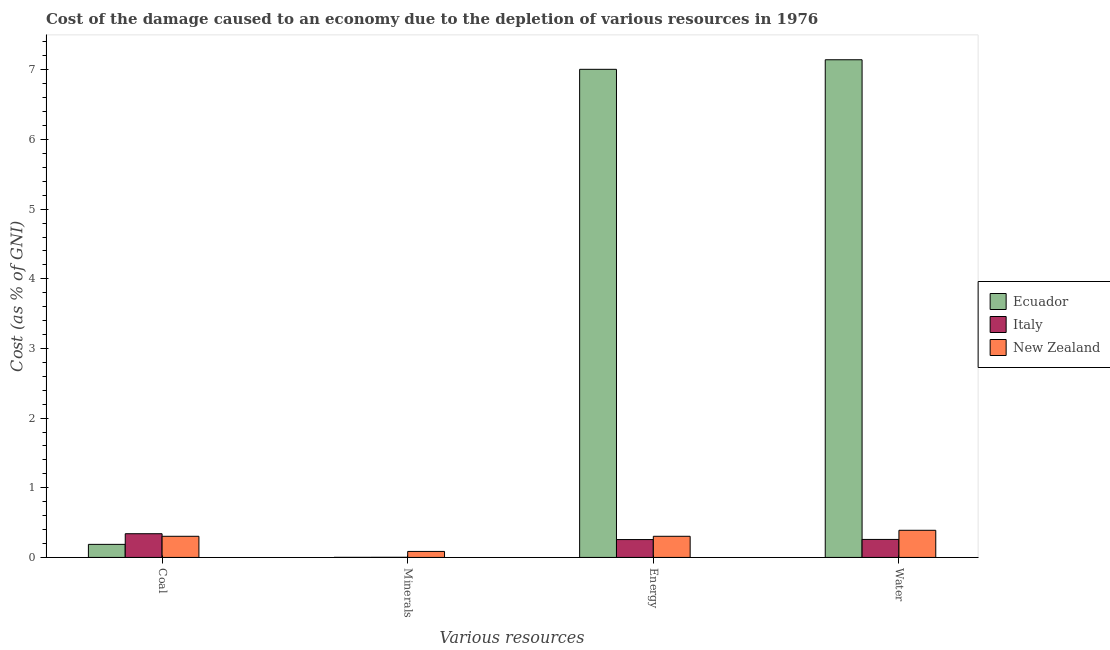How many different coloured bars are there?
Keep it short and to the point. 3. How many groups of bars are there?
Offer a terse response. 4. Are the number of bars on each tick of the X-axis equal?
Make the answer very short. Yes. What is the label of the 4th group of bars from the left?
Your response must be concise. Water. What is the cost of damage due to depletion of energy in Ecuador?
Keep it short and to the point. 7.01. Across all countries, what is the maximum cost of damage due to depletion of coal?
Your answer should be compact. 0.34. Across all countries, what is the minimum cost of damage due to depletion of energy?
Your response must be concise. 0.26. In which country was the cost of damage due to depletion of water maximum?
Offer a very short reply. Ecuador. In which country was the cost of damage due to depletion of minerals minimum?
Your response must be concise. Ecuador. What is the total cost of damage due to depletion of energy in the graph?
Your response must be concise. 7.57. What is the difference between the cost of damage due to depletion of water in Italy and that in Ecuador?
Provide a short and direct response. -6.89. What is the difference between the cost of damage due to depletion of energy in New Zealand and the cost of damage due to depletion of water in Italy?
Offer a terse response. 0.05. What is the average cost of damage due to depletion of water per country?
Make the answer very short. 2.6. What is the difference between the cost of damage due to depletion of coal and cost of damage due to depletion of energy in New Zealand?
Offer a terse response. -4.863200222998687e-5. In how many countries, is the cost of damage due to depletion of energy greater than 0.2 %?
Make the answer very short. 3. What is the ratio of the cost of damage due to depletion of energy in Ecuador to that in New Zealand?
Provide a succinct answer. 23.09. Is the cost of damage due to depletion of water in New Zealand less than that in Ecuador?
Provide a succinct answer. Yes. What is the difference between the highest and the second highest cost of damage due to depletion of energy?
Offer a very short reply. 6.7. What is the difference between the highest and the lowest cost of damage due to depletion of coal?
Make the answer very short. 0.15. In how many countries, is the cost of damage due to depletion of minerals greater than the average cost of damage due to depletion of minerals taken over all countries?
Your response must be concise. 1. What does the 3rd bar from the left in Minerals represents?
Your answer should be very brief. New Zealand. What does the 2nd bar from the right in Energy represents?
Your answer should be compact. Italy. Is it the case that in every country, the sum of the cost of damage due to depletion of coal and cost of damage due to depletion of minerals is greater than the cost of damage due to depletion of energy?
Keep it short and to the point. No. What is the difference between two consecutive major ticks on the Y-axis?
Your answer should be compact. 1. Are the values on the major ticks of Y-axis written in scientific E-notation?
Your answer should be very brief. No. Does the graph contain any zero values?
Offer a very short reply. No. How many legend labels are there?
Give a very brief answer. 3. What is the title of the graph?
Your answer should be compact. Cost of the damage caused to an economy due to the depletion of various resources in 1976 . Does "Spain" appear as one of the legend labels in the graph?
Make the answer very short. No. What is the label or title of the X-axis?
Make the answer very short. Various resources. What is the label or title of the Y-axis?
Offer a terse response. Cost (as % of GNI). What is the Cost (as % of GNI) of Ecuador in Coal?
Your response must be concise. 0.19. What is the Cost (as % of GNI) in Italy in Coal?
Your response must be concise. 0.34. What is the Cost (as % of GNI) of New Zealand in Coal?
Provide a short and direct response. 0.3. What is the Cost (as % of GNI) in Ecuador in Minerals?
Keep it short and to the point. 0. What is the Cost (as % of GNI) of Italy in Minerals?
Your response must be concise. 0. What is the Cost (as % of GNI) of New Zealand in Minerals?
Provide a succinct answer. 0.09. What is the Cost (as % of GNI) of Ecuador in Energy?
Provide a succinct answer. 7.01. What is the Cost (as % of GNI) of Italy in Energy?
Give a very brief answer. 0.26. What is the Cost (as % of GNI) of New Zealand in Energy?
Offer a very short reply. 0.3. What is the Cost (as % of GNI) of Ecuador in Water?
Your response must be concise. 7.14. What is the Cost (as % of GNI) in Italy in Water?
Ensure brevity in your answer.  0.26. What is the Cost (as % of GNI) of New Zealand in Water?
Ensure brevity in your answer.  0.39. Across all Various resources, what is the maximum Cost (as % of GNI) of Ecuador?
Your answer should be compact. 7.14. Across all Various resources, what is the maximum Cost (as % of GNI) of Italy?
Keep it short and to the point. 0.34. Across all Various resources, what is the maximum Cost (as % of GNI) in New Zealand?
Provide a succinct answer. 0.39. Across all Various resources, what is the minimum Cost (as % of GNI) in Ecuador?
Provide a short and direct response. 0. Across all Various resources, what is the minimum Cost (as % of GNI) of Italy?
Keep it short and to the point. 0. Across all Various resources, what is the minimum Cost (as % of GNI) in New Zealand?
Offer a very short reply. 0.09. What is the total Cost (as % of GNI) in Ecuador in the graph?
Your response must be concise. 14.34. What is the total Cost (as % of GNI) of Italy in the graph?
Your answer should be very brief. 0.86. What is the total Cost (as % of GNI) in New Zealand in the graph?
Ensure brevity in your answer.  1.08. What is the difference between the Cost (as % of GNI) of Ecuador in Coal and that in Minerals?
Provide a succinct answer. 0.19. What is the difference between the Cost (as % of GNI) of Italy in Coal and that in Minerals?
Provide a short and direct response. 0.34. What is the difference between the Cost (as % of GNI) in New Zealand in Coal and that in Minerals?
Give a very brief answer. 0.22. What is the difference between the Cost (as % of GNI) of Ecuador in Coal and that in Energy?
Offer a terse response. -6.82. What is the difference between the Cost (as % of GNI) in Italy in Coal and that in Energy?
Ensure brevity in your answer.  0.08. What is the difference between the Cost (as % of GNI) in New Zealand in Coal and that in Energy?
Provide a succinct answer. -0. What is the difference between the Cost (as % of GNI) in Ecuador in Coal and that in Water?
Keep it short and to the point. -6.96. What is the difference between the Cost (as % of GNI) of Italy in Coal and that in Water?
Offer a terse response. 0.08. What is the difference between the Cost (as % of GNI) of New Zealand in Coal and that in Water?
Your answer should be very brief. -0.09. What is the difference between the Cost (as % of GNI) in Ecuador in Minerals and that in Energy?
Your answer should be compact. -7.01. What is the difference between the Cost (as % of GNI) in Italy in Minerals and that in Energy?
Your answer should be compact. -0.25. What is the difference between the Cost (as % of GNI) of New Zealand in Minerals and that in Energy?
Provide a short and direct response. -0.22. What is the difference between the Cost (as % of GNI) of Ecuador in Minerals and that in Water?
Your answer should be compact. -7.14. What is the difference between the Cost (as % of GNI) in Italy in Minerals and that in Water?
Offer a terse response. -0.26. What is the difference between the Cost (as % of GNI) in New Zealand in Minerals and that in Water?
Make the answer very short. -0.3. What is the difference between the Cost (as % of GNI) in Ecuador in Energy and that in Water?
Provide a succinct answer. -0.14. What is the difference between the Cost (as % of GNI) in Italy in Energy and that in Water?
Offer a terse response. -0. What is the difference between the Cost (as % of GNI) of New Zealand in Energy and that in Water?
Your answer should be very brief. -0.09. What is the difference between the Cost (as % of GNI) in Ecuador in Coal and the Cost (as % of GNI) in Italy in Minerals?
Make the answer very short. 0.19. What is the difference between the Cost (as % of GNI) in Ecuador in Coal and the Cost (as % of GNI) in New Zealand in Minerals?
Offer a terse response. 0.1. What is the difference between the Cost (as % of GNI) in Italy in Coal and the Cost (as % of GNI) in New Zealand in Minerals?
Ensure brevity in your answer.  0.25. What is the difference between the Cost (as % of GNI) in Ecuador in Coal and the Cost (as % of GNI) in Italy in Energy?
Ensure brevity in your answer.  -0.07. What is the difference between the Cost (as % of GNI) of Ecuador in Coal and the Cost (as % of GNI) of New Zealand in Energy?
Your answer should be very brief. -0.12. What is the difference between the Cost (as % of GNI) of Italy in Coal and the Cost (as % of GNI) of New Zealand in Energy?
Provide a short and direct response. 0.04. What is the difference between the Cost (as % of GNI) in Ecuador in Coal and the Cost (as % of GNI) in Italy in Water?
Offer a terse response. -0.07. What is the difference between the Cost (as % of GNI) in Ecuador in Coal and the Cost (as % of GNI) in New Zealand in Water?
Ensure brevity in your answer.  -0.2. What is the difference between the Cost (as % of GNI) in Italy in Coal and the Cost (as % of GNI) in New Zealand in Water?
Your response must be concise. -0.05. What is the difference between the Cost (as % of GNI) of Ecuador in Minerals and the Cost (as % of GNI) of Italy in Energy?
Offer a terse response. -0.26. What is the difference between the Cost (as % of GNI) of Ecuador in Minerals and the Cost (as % of GNI) of New Zealand in Energy?
Keep it short and to the point. -0.3. What is the difference between the Cost (as % of GNI) of Italy in Minerals and the Cost (as % of GNI) of New Zealand in Energy?
Provide a short and direct response. -0.3. What is the difference between the Cost (as % of GNI) in Ecuador in Minerals and the Cost (as % of GNI) in Italy in Water?
Make the answer very short. -0.26. What is the difference between the Cost (as % of GNI) of Ecuador in Minerals and the Cost (as % of GNI) of New Zealand in Water?
Offer a very short reply. -0.39. What is the difference between the Cost (as % of GNI) of Italy in Minerals and the Cost (as % of GNI) of New Zealand in Water?
Your response must be concise. -0.39. What is the difference between the Cost (as % of GNI) in Ecuador in Energy and the Cost (as % of GNI) in Italy in Water?
Your answer should be compact. 6.75. What is the difference between the Cost (as % of GNI) of Ecuador in Energy and the Cost (as % of GNI) of New Zealand in Water?
Provide a succinct answer. 6.62. What is the difference between the Cost (as % of GNI) in Italy in Energy and the Cost (as % of GNI) in New Zealand in Water?
Your response must be concise. -0.13. What is the average Cost (as % of GNI) of Ecuador per Various resources?
Your answer should be compact. 3.59. What is the average Cost (as % of GNI) in Italy per Various resources?
Offer a very short reply. 0.21. What is the average Cost (as % of GNI) in New Zealand per Various resources?
Give a very brief answer. 0.27. What is the difference between the Cost (as % of GNI) of Ecuador and Cost (as % of GNI) of Italy in Coal?
Your response must be concise. -0.15. What is the difference between the Cost (as % of GNI) in Ecuador and Cost (as % of GNI) in New Zealand in Coal?
Provide a succinct answer. -0.12. What is the difference between the Cost (as % of GNI) in Italy and Cost (as % of GNI) in New Zealand in Coal?
Provide a succinct answer. 0.04. What is the difference between the Cost (as % of GNI) in Ecuador and Cost (as % of GNI) in Italy in Minerals?
Make the answer very short. -0. What is the difference between the Cost (as % of GNI) of Ecuador and Cost (as % of GNI) of New Zealand in Minerals?
Give a very brief answer. -0.09. What is the difference between the Cost (as % of GNI) in Italy and Cost (as % of GNI) in New Zealand in Minerals?
Ensure brevity in your answer.  -0.08. What is the difference between the Cost (as % of GNI) in Ecuador and Cost (as % of GNI) in Italy in Energy?
Keep it short and to the point. 6.75. What is the difference between the Cost (as % of GNI) in Ecuador and Cost (as % of GNI) in New Zealand in Energy?
Your answer should be very brief. 6.7. What is the difference between the Cost (as % of GNI) of Italy and Cost (as % of GNI) of New Zealand in Energy?
Your answer should be compact. -0.05. What is the difference between the Cost (as % of GNI) in Ecuador and Cost (as % of GNI) in Italy in Water?
Your response must be concise. 6.89. What is the difference between the Cost (as % of GNI) of Ecuador and Cost (as % of GNI) of New Zealand in Water?
Keep it short and to the point. 6.76. What is the difference between the Cost (as % of GNI) in Italy and Cost (as % of GNI) in New Zealand in Water?
Offer a very short reply. -0.13. What is the ratio of the Cost (as % of GNI) in Ecuador in Coal to that in Minerals?
Provide a short and direct response. 193.22. What is the ratio of the Cost (as % of GNI) of Italy in Coal to that in Minerals?
Make the answer very short. 184.48. What is the ratio of the Cost (as % of GNI) in New Zealand in Coal to that in Minerals?
Your answer should be very brief. 3.52. What is the ratio of the Cost (as % of GNI) of Ecuador in Coal to that in Energy?
Your response must be concise. 0.03. What is the ratio of the Cost (as % of GNI) in Italy in Coal to that in Energy?
Offer a terse response. 1.33. What is the ratio of the Cost (as % of GNI) of Ecuador in Coal to that in Water?
Make the answer very short. 0.03. What is the ratio of the Cost (as % of GNI) in Italy in Coal to that in Water?
Give a very brief answer. 1.32. What is the ratio of the Cost (as % of GNI) of New Zealand in Coal to that in Water?
Your response must be concise. 0.78. What is the ratio of the Cost (as % of GNI) of Ecuador in Minerals to that in Energy?
Make the answer very short. 0. What is the ratio of the Cost (as % of GNI) of Italy in Minerals to that in Energy?
Provide a short and direct response. 0.01. What is the ratio of the Cost (as % of GNI) of New Zealand in Minerals to that in Energy?
Provide a short and direct response. 0.28. What is the ratio of the Cost (as % of GNI) of Italy in Minerals to that in Water?
Your response must be concise. 0.01. What is the ratio of the Cost (as % of GNI) of New Zealand in Minerals to that in Water?
Provide a succinct answer. 0.22. What is the ratio of the Cost (as % of GNI) of Ecuador in Energy to that in Water?
Ensure brevity in your answer.  0.98. What is the ratio of the Cost (as % of GNI) in Italy in Energy to that in Water?
Your response must be concise. 0.99. What is the ratio of the Cost (as % of GNI) in New Zealand in Energy to that in Water?
Offer a terse response. 0.78. What is the difference between the highest and the second highest Cost (as % of GNI) in Ecuador?
Your answer should be very brief. 0.14. What is the difference between the highest and the second highest Cost (as % of GNI) in Italy?
Ensure brevity in your answer.  0.08. What is the difference between the highest and the second highest Cost (as % of GNI) in New Zealand?
Your response must be concise. 0.09. What is the difference between the highest and the lowest Cost (as % of GNI) of Ecuador?
Your answer should be very brief. 7.14. What is the difference between the highest and the lowest Cost (as % of GNI) of Italy?
Give a very brief answer. 0.34. What is the difference between the highest and the lowest Cost (as % of GNI) of New Zealand?
Offer a very short reply. 0.3. 